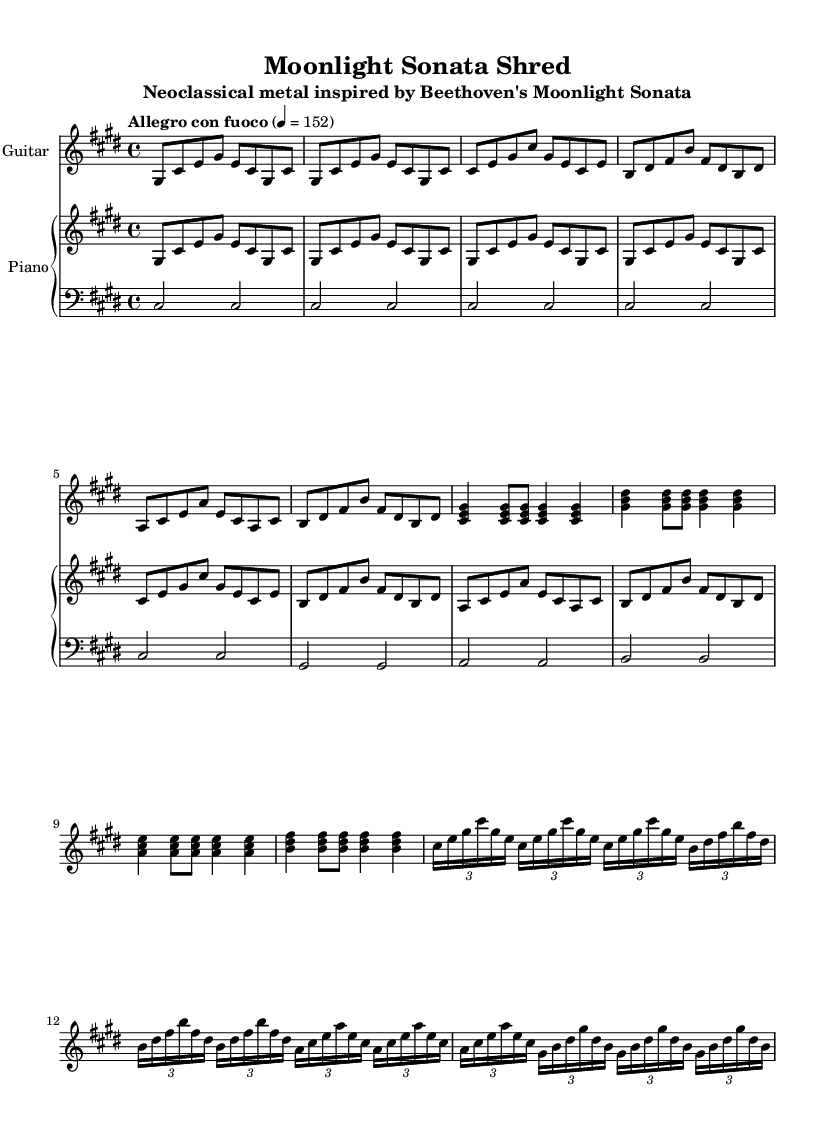What is the key signature of this music? The key signature is indicated at the beginning of the staff with sharps. In this case, it has four sharps, which corresponds to the key of C sharp minor.
Answer: C sharp minor What is the time signature used in this piece? The time signature is displayed after the key signature in the form of a fraction. Here, it shows four beats in a measure, indicating a 4/4 time signature.
Answer: 4/4 What is the tempo marking for this music? The tempo marking is located above the staff and specifies the speed of the piece. Here, it states "Allegro con fuoco" with a metronome marking of 152 beats per minute.
Answer: Allegro con fuoco How many measures are in the guitar solo section? To find the number of measures, we need to count the distinct sections of notation in the guitar solo. The guitar solo consists of four distinct groupings, each representing measures.
Answer: 4 Which classical piece inspired this composition? The title of the piece references Beethoven's "Moonlight Sonata," indicating that it's a neoclassical metal adaptation of this classical work.
Answer: Moonlight Sonata What type of guitar chords are used in the chorus? The guitar chorus section features specific chord voicings that are characterized by using the notes C sharp, E, G sharp, and variations of these notes, which can be identified as major chords.
Answer: Major chords What is the significance of the tuplet notation in the guitar solo? Tuplet notation indicates a grouping of notes played in a specific rhythmic pattern that divides the beat differently than standard notation. Here, it shows that the four notes are played in the time typically assigned to three, indicating a triplet feel.
Answer: Triplet feel 